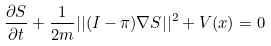Convert formula to latex. <formula><loc_0><loc_0><loc_500><loc_500>\frac { \partial { S } } { \partial { t } } + \frac { 1 } { 2 m } | | ( I - \pi ) \nabla { S } | | ^ { 2 } + V ( x ) = 0</formula> 